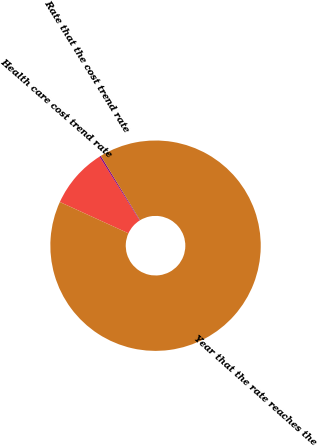Convert chart. <chart><loc_0><loc_0><loc_500><loc_500><pie_chart><fcel>Health care cost trend rate<fcel>Rate that the cost trend rate<fcel>Year that the rate reaches the<nl><fcel>9.25%<fcel>0.22%<fcel>90.52%<nl></chart> 